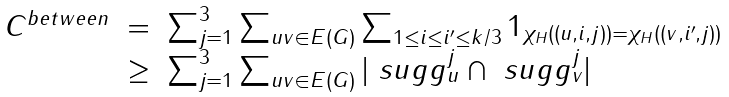Convert formula to latex. <formula><loc_0><loc_0><loc_500><loc_500>\begin{array} { r c l r } C ^ { b e t w e e n } & = & \sum _ { j = 1 } ^ { 3 } \sum _ { u v \in E ( G ) } \sum _ { 1 \leq i \leq i ^ { \prime } \leq k / 3 } 1 _ { \chi _ { H } ( ( u , i , j ) ) = \chi _ { H } ( ( v , i ^ { \prime } , j ) ) } \\ & \geq & \sum _ { j = 1 } ^ { 3 } \sum _ { u v \in E ( G ) } | \ s u g g ^ { j } _ { u } \cap \ s u g g ^ { j } _ { v } | \end{array}</formula> 